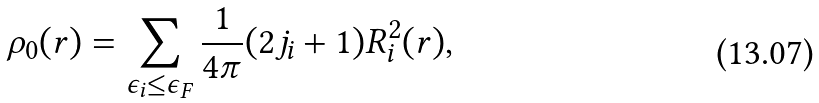Convert formula to latex. <formula><loc_0><loc_0><loc_500><loc_500>\rho _ { 0 } ( r ) = \sum _ { \epsilon _ { i } \leq \epsilon _ { F } } \frac { 1 } { 4 \pi } ( 2 j _ { i } + 1 ) R ^ { 2 } _ { i } ( r ) ,</formula> 